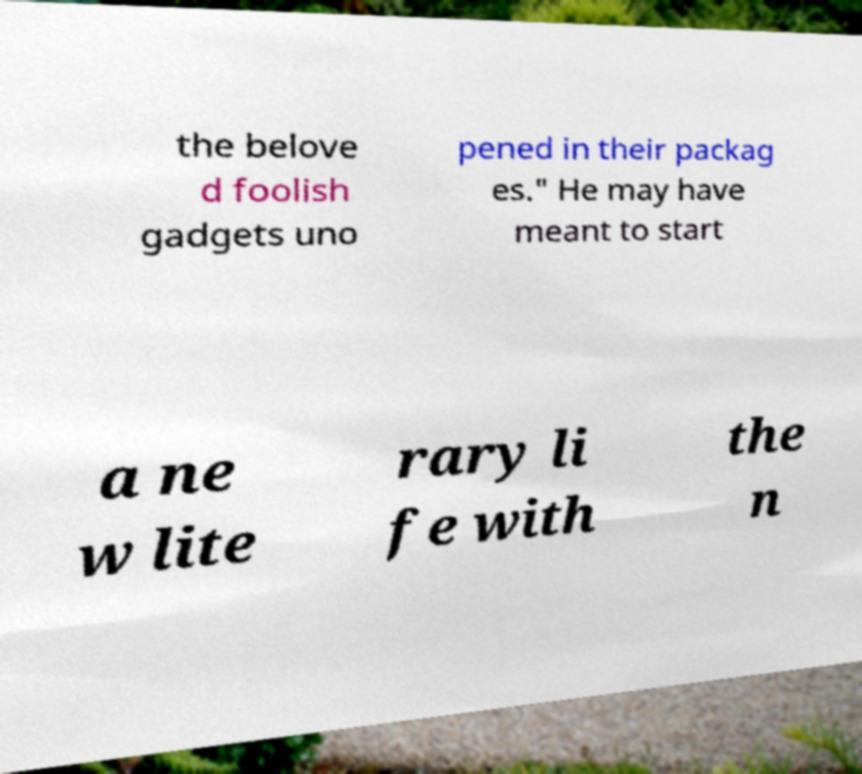What messages or text are displayed in this image? I need them in a readable, typed format. the belove d foolish gadgets uno pened in their packag es." He may have meant to start a ne w lite rary li fe with the n 